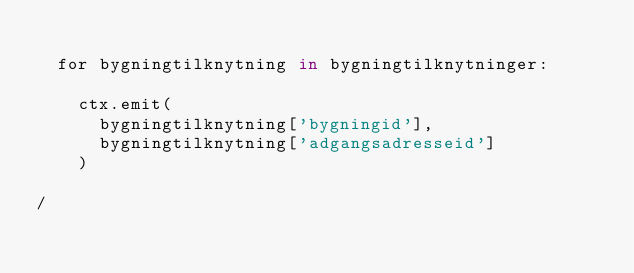<code> <loc_0><loc_0><loc_500><loc_500><_SQL_>
	for bygningtilknytning in bygningtilknytninger:

		ctx.emit(
			bygningtilknytning['bygningid'],
			bygningtilknytning['adgangsadresseid']
		)

/
</code> 